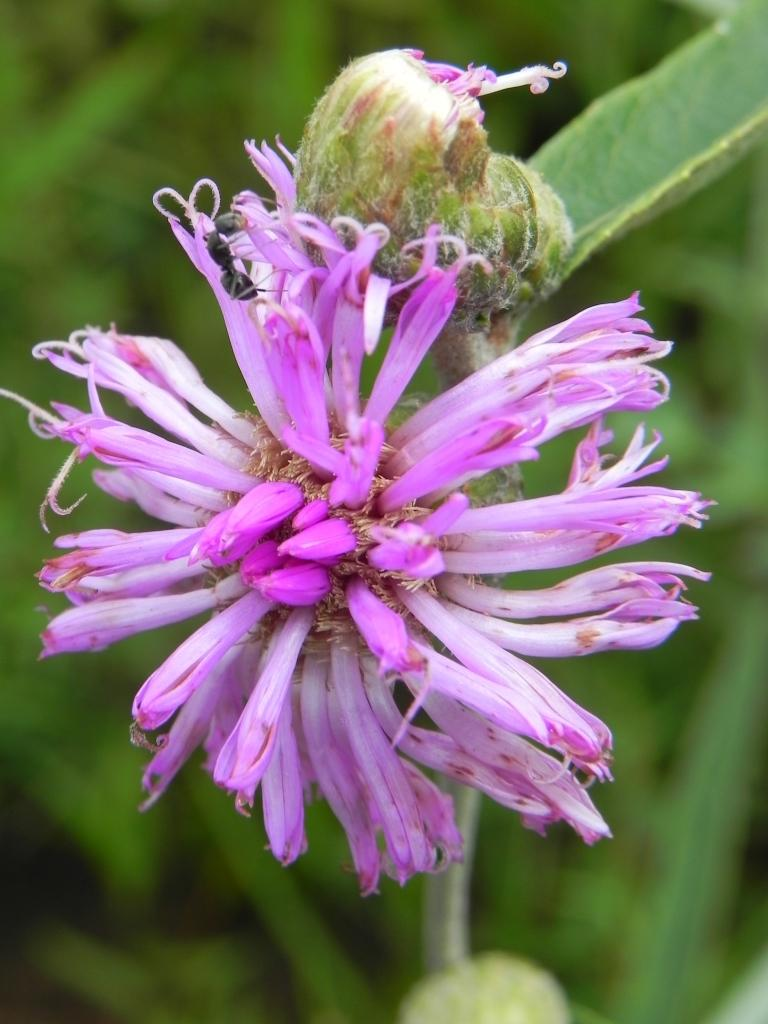What color is the flower in the image? The flower in the image is pink. How many petals does the flower have? The flower has many petals. What can be seen in the background of the image? There are green leaves in the background of the image. What type of verse can be heard recited by the sheep in the image? There are no sheep present in the image, and therefore no verses can be heard. 